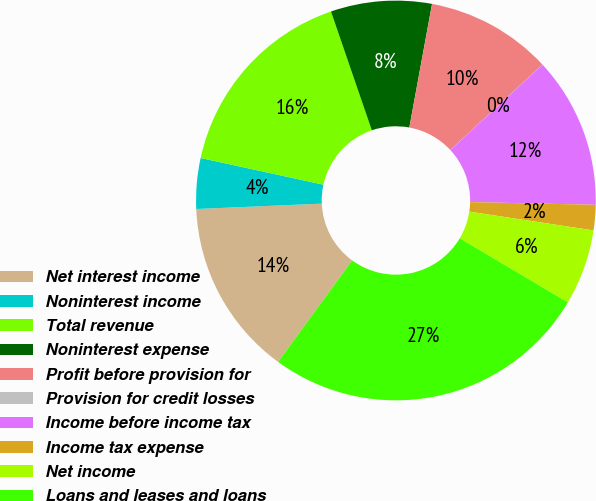Convert chart. <chart><loc_0><loc_0><loc_500><loc_500><pie_chart><fcel>Net interest income<fcel>Noninterest income<fcel>Total revenue<fcel>Noninterest expense<fcel>Profit before provision for<fcel>Provision for credit losses<fcel>Income before income tax<fcel>Income tax expense<fcel>Net income<fcel>Loans and leases and loans<nl><fcel>14.28%<fcel>4.09%<fcel>16.32%<fcel>8.16%<fcel>10.2%<fcel>0.01%<fcel>12.24%<fcel>2.05%<fcel>6.12%<fcel>26.52%<nl></chart> 